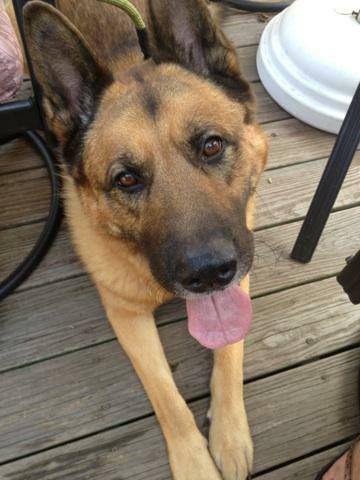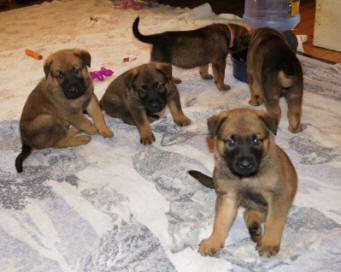The first image is the image on the left, the second image is the image on the right. Considering the images on both sides, is "At least one image has no grass." valid? Answer yes or no. Yes. The first image is the image on the left, the second image is the image on the right. Examine the images to the left and right. Is the description "the dog's tongue is extended in one of the images" accurate? Answer yes or no. Yes. 